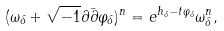<formula> <loc_0><loc_0><loc_500><loc_500>( \omega _ { \delta } + \sqrt { - 1 } \partial \bar { \partial } \varphi _ { \delta } ) ^ { n } = e ^ { h _ { \delta } - t \varphi _ { \delta } } \omega _ { \delta } ^ { n } ,</formula> 